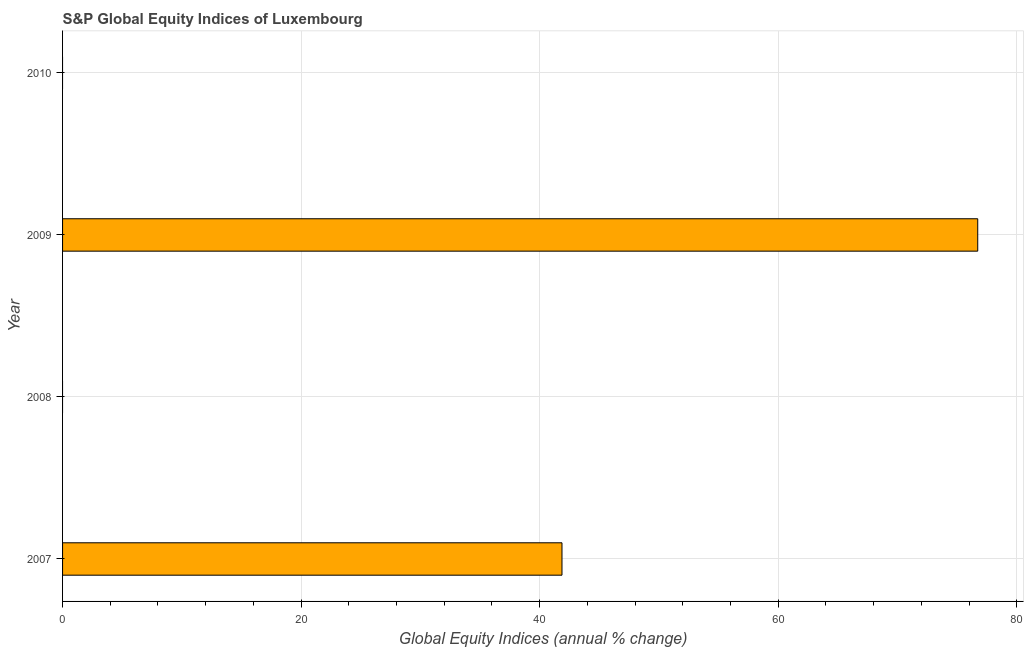Does the graph contain any zero values?
Provide a short and direct response. Yes. What is the title of the graph?
Your response must be concise. S&P Global Equity Indices of Luxembourg. What is the label or title of the X-axis?
Keep it short and to the point. Global Equity Indices (annual % change). What is the s&p global equity indices in 2010?
Your response must be concise. 0. Across all years, what is the maximum s&p global equity indices?
Offer a very short reply. 76.73. What is the sum of the s&p global equity indices?
Offer a terse response. 118.61. What is the average s&p global equity indices per year?
Provide a succinct answer. 29.65. What is the median s&p global equity indices?
Your answer should be very brief. 20.94. In how many years, is the s&p global equity indices greater than 44 %?
Make the answer very short. 1. Is the s&p global equity indices in 2007 less than that in 2009?
Your answer should be compact. Yes. What is the difference between the highest and the lowest s&p global equity indices?
Offer a very short reply. 76.73. In how many years, is the s&p global equity indices greater than the average s&p global equity indices taken over all years?
Offer a very short reply. 2. Are all the bars in the graph horizontal?
Ensure brevity in your answer.  Yes. How many years are there in the graph?
Offer a terse response. 4. What is the Global Equity Indices (annual % change) of 2007?
Ensure brevity in your answer.  41.87. What is the Global Equity Indices (annual % change) of 2008?
Your response must be concise. 0. What is the Global Equity Indices (annual % change) of 2009?
Your answer should be compact. 76.73. What is the Global Equity Indices (annual % change) in 2010?
Your answer should be compact. 0. What is the difference between the Global Equity Indices (annual % change) in 2007 and 2009?
Provide a succinct answer. -34.86. What is the ratio of the Global Equity Indices (annual % change) in 2007 to that in 2009?
Give a very brief answer. 0.55. 